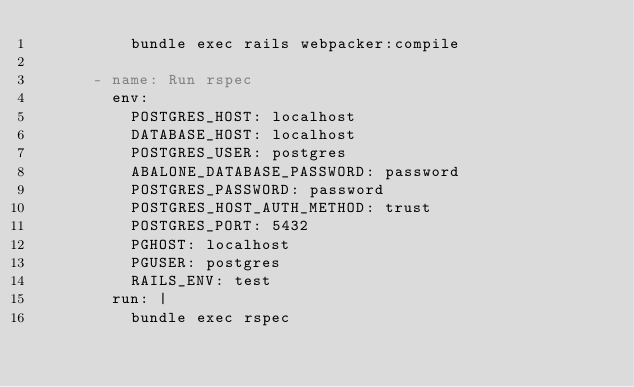Convert code to text. <code><loc_0><loc_0><loc_500><loc_500><_YAML_>          bundle exec rails webpacker:compile

      - name: Run rspec
        env:
          POSTGRES_HOST: localhost
          DATABASE_HOST: localhost
          POSTGRES_USER: postgres
          ABALONE_DATABASE_PASSWORD: password
          POSTGRES_PASSWORD: password
          POSTGRES_HOST_AUTH_METHOD: trust
          POSTGRES_PORT: 5432
          PGHOST: localhost
          PGUSER: postgres
          RAILS_ENV: test
        run: |
          bundle exec rspec</code> 